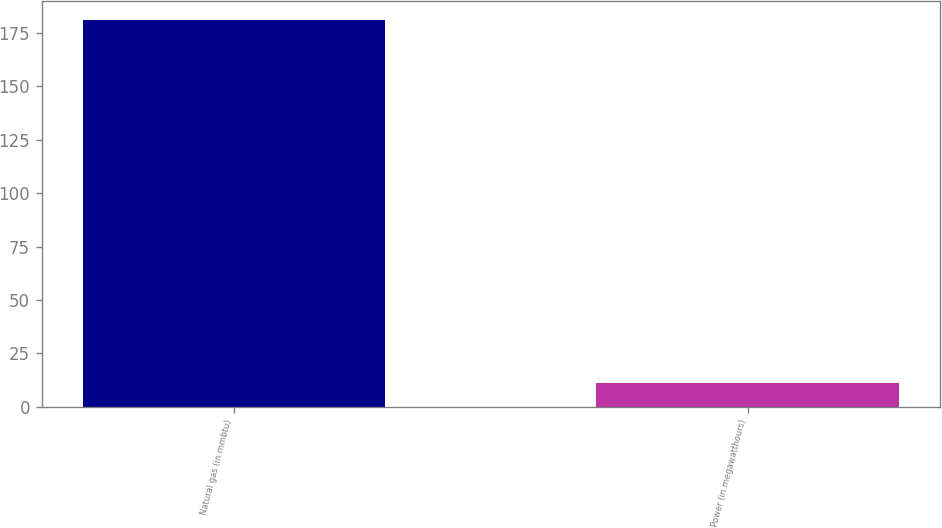<chart> <loc_0><loc_0><loc_500><loc_500><bar_chart><fcel>Natural gas (in mmbtu)<fcel>Power (in megawatthours)<nl><fcel>181<fcel>11<nl></chart> 